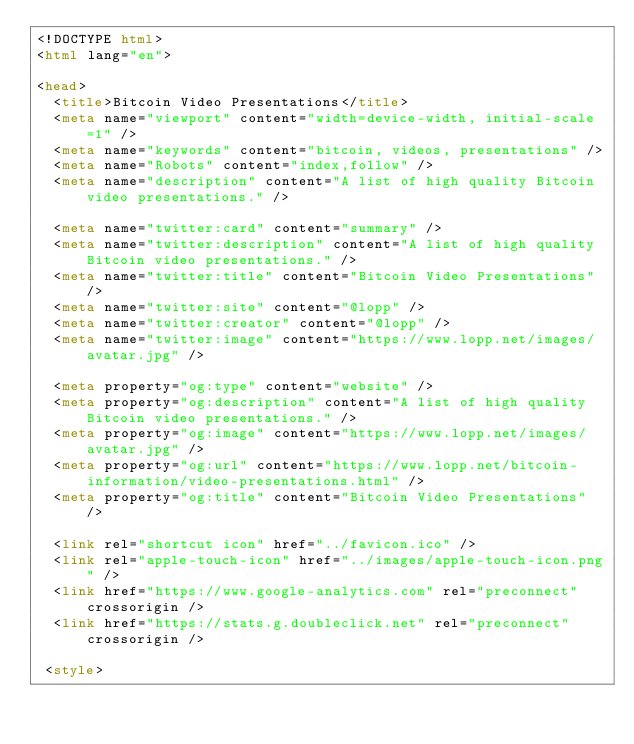<code> <loc_0><loc_0><loc_500><loc_500><_HTML_><!DOCTYPE html>
<html lang="en">

<head>
  <title>Bitcoin Video Presentations</title>
  <meta name="viewport" content="width=device-width, initial-scale=1" />
  <meta name="keywords" content="bitcoin, videos, presentations" />
  <meta name="Robots" content="index,follow" />
  <meta name="description" content="A list of high quality Bitcoin video presentations." />

  <meta name="twitter:card" content="summary" />
  <meta name="twitter:description" content="A list of high quality Bitcoin video presentations." />
  <meta name="twitter:title" content="Bitcoin Video Presentations" />
  <meta name="twitter:site" content="@lopp" />
  <meta name="twitter:creator" content="@lopp" />
  <meta name="twitter:image" content="https://www.lopp.net/images/avatar.jpg" />

  <meta property="og:type" content="website" />
  <meta property="og:description" content="A list of high quality Bitcoin video presentations." />
  <meta property="og:image" content="https://www.lopp.net/images/avatar.jpg" />
  <meta property="og:url" content="https://www.lopp.net/bitcoin-information/video-presentations.html" />
  <meta property="og:title" content="Bitcoin Video Presentations" />

  <link rel="shortcut icon" href="../favicon.ico" />
  <link rel="apple-touch-icon" href="../images/apple-touch-icon.png" />
  <link href="https://www.google-analytics.com" rel="preconnect" crossorigin />
  <link href="https://stats.g.doubleclick.net" rel="preconnect" crossorigin />

 <style></code> 